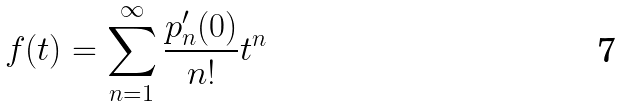<formula> <loc_0><loc_0><loc_500><loc_500>f ( t ) = \sum _ { n = 1 } ^ { \infty } \frac { p _ { n } ^ { \prime } ( 0 ) } { n ! } t ^ { n }</formula> 